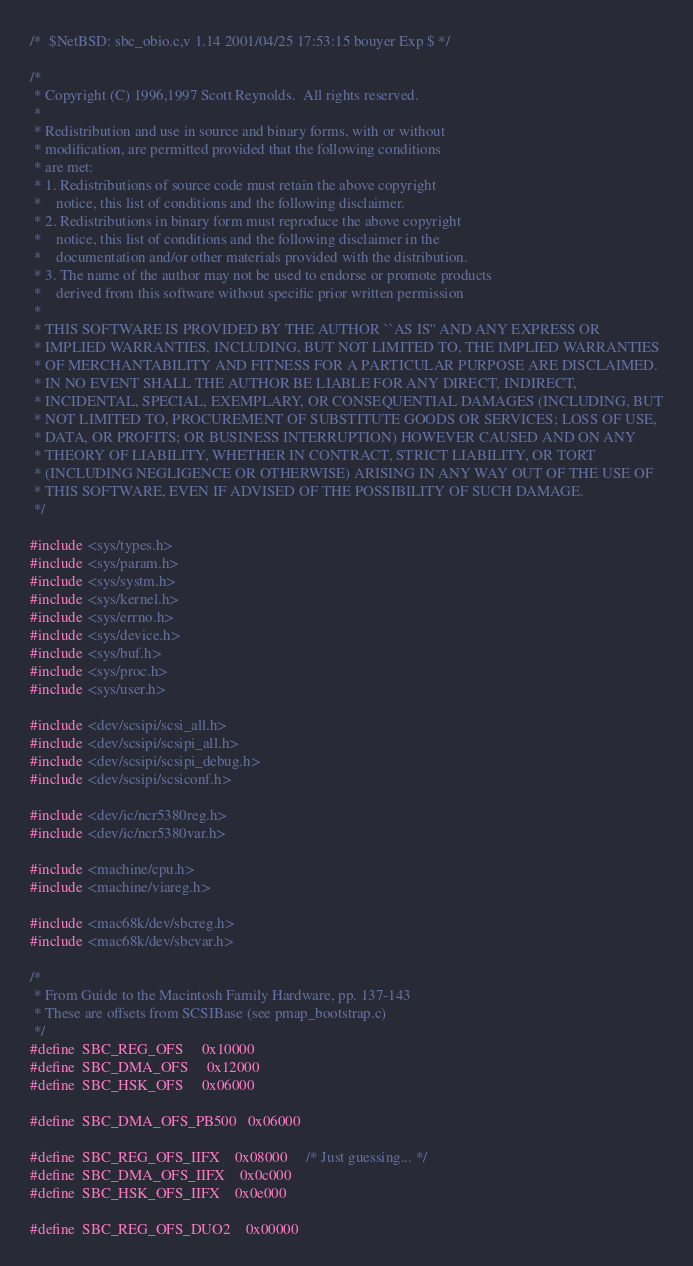<code> <loc_0><loc_0><loc_500><loc_500><_C_>/*	$NetBSD: sbc_obio.c,v 1.14 2001/04/25 17:53:15 bouyer Exp $	*/

/*
 * Copyright (C) 1996,1997 Scott Reynolds.  All rights reserved.
 *
 * Redistribution and use in source and binary forms, with or without
 * modification, are permitted provided that the following conditions
 * are met:
 * 1. Redistributions of source code must retain the above copyright
 *    notice, this list of conditions and the following disclaimer.
 * 2. Redistributions in binary form must reproduce the above copyright
 *    notice, this list of conditions and the following disclaimer in the
 *    documentation and/or other materials provided with the distribution.
 * 3. The name of the author may not be used to endorse or promote products
 *    derived from this software without specific prior written permission
 *
 * THIS SOFTWARE IS PROVIDED BY THE AUTHOR ``AS IS'' AND ANY EXPRESS OR
 * IMPLIED WARRANTIES, INCLUDING, BUT NOT LIMITED TO, THE IMPLIED WARRANTIES
 * OF MERCHANTABILITY AND FITNESS FOR A PARTICULAR PURPOSE ARE DISCLAIMED.
 * IN NO EVENT SHALL THE AUTHOR BE LIABLE FOR ANY DIRECT, INDIRECT,
 * INCIDENTAL, SPECIAL, EXEMPLARY, OR CONSEQUENTIAL DAMAGES (INCLUDING, BUT
 * NOT LIMITED TO, PROCUREMENT OF SUBSTITUTE GOODS OR SERVICES; LOSS OF USE,
 * DATA, OR PROFITS; OR BUSINESS INTERRUPTION) HOWEVER CAUSED AND ON ANY
 * THEORY OF LIABILITY, WHETHER IN CONTRACT, STRICT LIABILITY, OR TORT
 * (INCLUDING NEGLIGENCE OR OTHERWISE) ARISING IN ANY WAY OUT OF THE USE OF
 * THIS SOFTWARE, EVEN IF ADVISED OF THE POSSIBILITY OF SUCH DAMAGE.
 */

#include <sys/types.h>
#include <sys/param.h>
#include <sys/systm.h>
#include <sys/kernel.h>
#include <sys/errno.h>
#include <sys/device.h>
#include <sys/buf.h>
#include <sys/proc.h>
#include <sys/user.h>

#include <dev/scsipi/scsi_all.h>
#include <dev/scsipi/scsipi_all.h>
#include <dev/scsipi/scsipi_debug.h>
#include <dev/scsipi/scsiconf.h>

#include <dev/ic/ncr5380reg.h>
#include <dev/ic/ncr5380var.h>

#include <machine/cpu.h>
#include <machine/viareg.h>

#include <mac68k/dev/sbcreg.h>
#include <mac68k/dev/sbcvar.h>

/*
 * From Guide to the Macintosh Family Hardware, pp. 137-143
 * These are offsets from SCSIBase (see pmap_bootstrap.c)
 */
#define	SBC_REG_OFS		0x10000
#define	SBC_DMA_OFS		0x12000
#define	SBC_HSK_OFS		0x06000

#define	SBC_DMA_OFS_PB500	0x06000

#define	SBC_REG_OFS_IIFX	0x08000		/* Just guessing... */
#define	SBC_DMA_OFS_IIFX	0x0c000
#define	SBC_HSK_OFS_IIFX	0x0e000

#define	SBC_REG_OFS_DUO2	0x00000</code> 